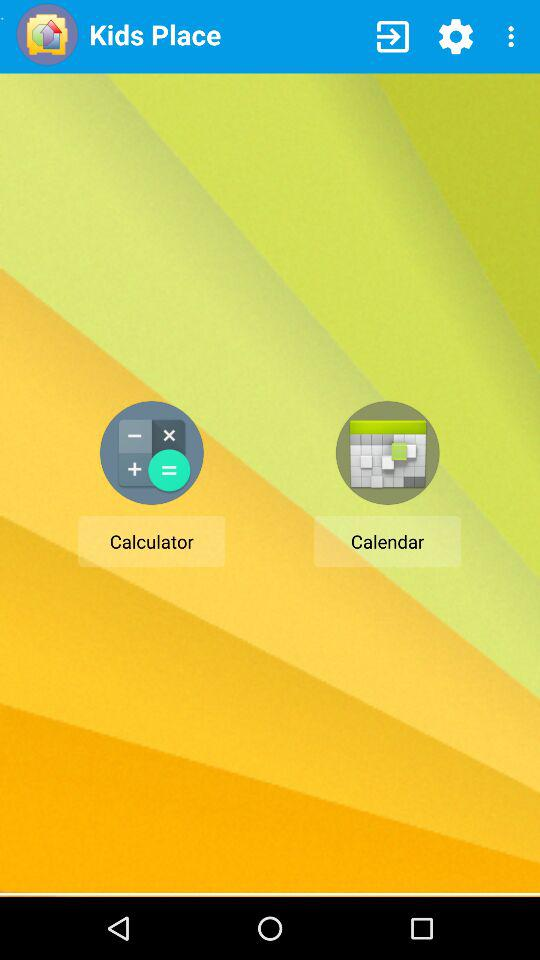What is the application name? The application name is "Kids Place". 